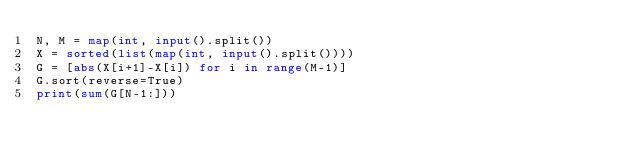<code> <loc_0><loc_0><loc_500><loc_500><_Python_>N, M = map(int, input().split())
X = sorted(list(map(int, input().split())))
G = [abs(X[i+1]-X[i]) for i in range(M-1)]
G.sort(reverse=True)
print(sum(G[N-1:]))</code> 